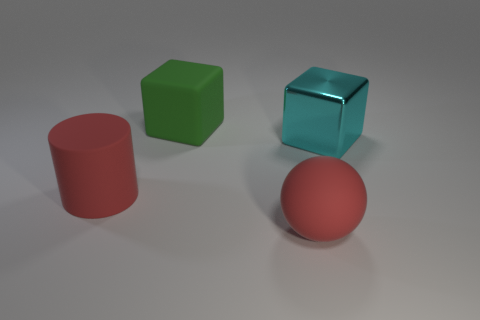Is there another thing that has the same shape as the cyan metallic object?
Provide a succinct answer. Yes. There is a big red thing on the left side of the big red rubber object right of the matte object behind the large cyan shiny object; what is its material?
Provide a short and direct response. Rubber. What is the color of the large rubber cube?
Ensure brevity in your answer.  Green. How many metallic objects are blocks or large cyan cubes?
Provide a succinct answer. 1. Is there anything else that is the same material as the red sphere?
Your response must be concise. Yes. Is the color of the big sphere that is left of the cyan shiny thing the same as the big thing to the left of the rubber block?
Offer a very short reply. Yes. There is a big matte cylinder; what number of matte spheres are behind it?
Offer a terse response. 0. There is a red rubber thing behind the red object in front of the large red cylinder; is there a cyan cube that is behind it?
Provide a succinct answer. Yes. How many green cylinders are the same size as the metallic thing?
Your answer should be very brief. 0. What is the big thing that is in front of the large red object behind the large rubber sphere made of?
Give a very brief answer. Rubber. 